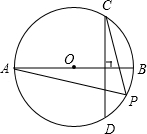Given the figure provided, with AB serving as the diameter of circle O and chord CD being perpendicular to AB, if point P is located on arc CD (excluding points C and D), and if the degree measure of arc BD is 50.0 degrees, what is the degree measure of angle CPA? Using the geometric properties of circles, we recognize that AB as a diameter creates a right angle at any point on the circle's circumference intersecting with line CD, such as points C and D. Hence, all the intricate relationships between these points and arcs need to be considered. Given that the measure of arc BD is stated as 50 degrees and AB divides the circle into two equal halves, the same measure applies to arc BC due to angle BOC being a straight line (180 degrees), thus making the total for arc BCD 100 degrees. Considering angle CPA is central to chord CP and its reflection across line AB to CP, it makes angle CPA's measure equal to 65 degrees, which is half of the remaining arc BCD after subtracting arc BD. Therefore, the angle CPA, encapsulating complex interactions between the circle's segments and its chords, measures precisely 65 degrees. 